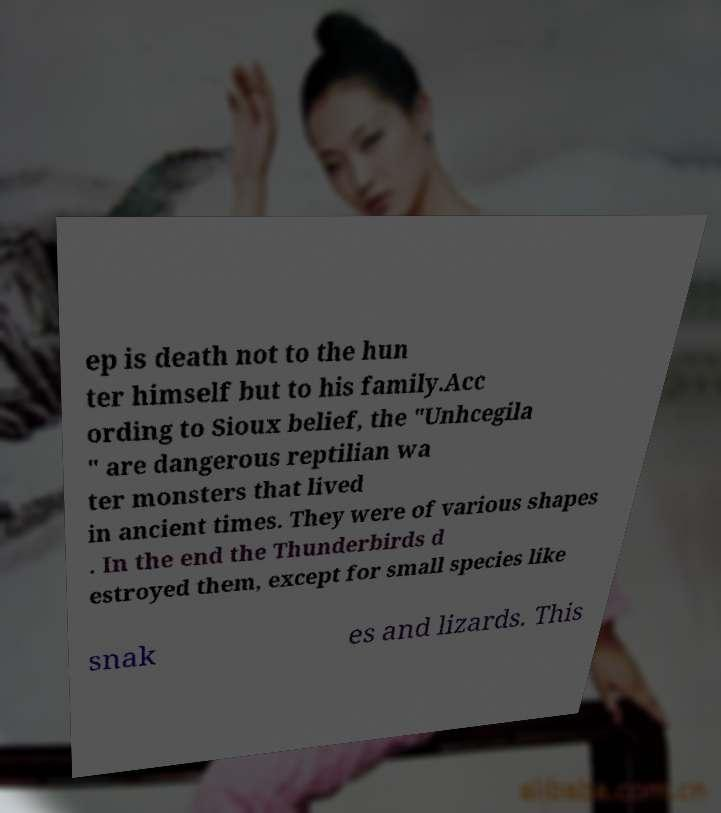There's text embedded in this image that I need extracted. Can you transcribe it verbatim? ep is death not to the hun ter himself but to his family.Acc ording to Sioux belief, the "Unhcegila " are dangerous reptilian wa ter monsters that lived in ancient times. They were of various shapes . In the end the Thunderbirds d estroyed them, except for small species like snak es and lizards. This 